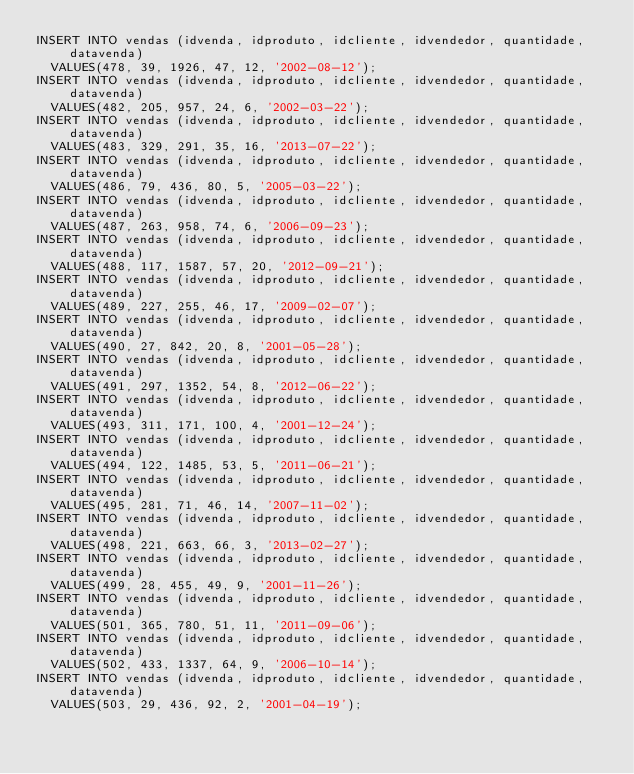Convert code to text. <code><loc_0><loc_0><loc_500><loc_500><_SQL_>INSERT INTO vendas (idvenda, idproduto, idcliente, idvendedor, quantidade, datavenda)
  VALUES(478, 39, 1926, 47, 12, '2002-08-12');
INSERT INTO vendas (idvenda, idproduto, idcliente, idvendedor, quantidade, datavenda)
  VALUES(482, 205, 957, 24, 6, '2002-03-22');
INSERT INTO vendas (idvenda, idproduto, idcliente, idvendedor, quantidade, datavenda)
  VALUES(483, 329, 291, 35, 16, '2013-07-22');
INSERT INTO vendas (idvenda, idproduto, idcliente, idvendedor, quantidade, datavenda)
  VALUES(486, 79, 436, 80, 5, '2005-03-22');
INSERT INTO vendas (idvenda, idproduto, idcliente, idvendedor, quantidade, datavenda)
  VALUES(487, 263, 958, 74, 6, '2006-09-23');
INSERT INTO vendas (idvenda, idproduto, idcliente, idvendedor, quantidade, datavenda)
  VALUES(488, 117, 1587, 57, 20, '2012-09-21');
INSERT INTO vendas (idvenda, idproduto, idcliente, idvendedor, quantidade, datavenda)
  VALUES(489, 227, 255, 46, 17, '2009-02-07');
INSERT INTO vendas (idvenda, idproduto, idcliente, idvendedor, quantidade, datavenda)
  VALUES(490, 27, 842, 20, 8, '2001-05-28');
INSERT INTO vendas (idvenda, idproduto, idcliente, idvendedor, quantidade, datavenda)
  VALUES(491, 297, 1352, 54, 8, '2012-06-22');
INSERT INTO vendas (idvenda, idproduto, idcliente, idvendedor, quantidade, datavenda)
  VALUES(493, 311, 171, 100, 4, '2001-12-24');
INSERT INTO vendas (idvenda, idproduto, idcliente, idvendedor, quantidade, datavenda)
  VALUES(494, 122, 1485, 53, 5, '2011-06-21');
INSERT INTO vendas (idvenda, idproduto, idcliente, idvendedor, quantidade, datavenda)
  VALUES(495, 281, 71, 46, 14, '2007-11-02');
INSERT INTO vendas (idvenda, idproduto, idcliente, idvendedor, quantidade, datavenda)
  VALUES(498, 221, 663, 66, 3, '2013-02-27');
INSERT INTO vendas (idvenda, idproduto, idcliente, idvendedor, quantidade, datavenda)
  VALUES(499, 28, 455, 49, 9, '2001-11-26');
INSERT INTO vendas (idvenda, idproduto, idcliente, idvendedor, quantidade, datavenda)
  VALUES(501, 365, 780, 51, 11, '2011-09-06');
INSERT INTO vendas (idvenda, idproduto, idcliente, idvendedor, quantidade, datavenda)
  VALUES(502, 433, 1337, 64, 9, '2006-10-14');
INSERT INTO vendas (idvenda, idproduto, idcliente, idvendedor, quantidade, datavenda)
  VALUES(503, 29, 436, 92, 2, '2001-04-19');</code> 